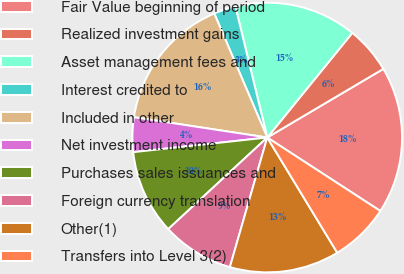<chart> <loc_0><loc_0><loc_500><loc_500><pie_chart><fcel>Fair Value beginning of period<fcel>Realized investment gains<fcel>Asset management fees and<fcel>Interest credited to<fcel>Included in other<fcel>Net investment income<fcel>Purchases sales issuances and<fcel>Foreign currency translation<fcel>Other(1)<fcel>Transfers into Level 3(2)<nl><fcel>17.67%<fcel>5.64%<fcel>14.66%<fcel>2.63%<fcel>16.17%<fcel>4.14%<fcel>10.15%<fcel>8.65%<fcel>13.16%<fcel>7.14%<nl></chart> 